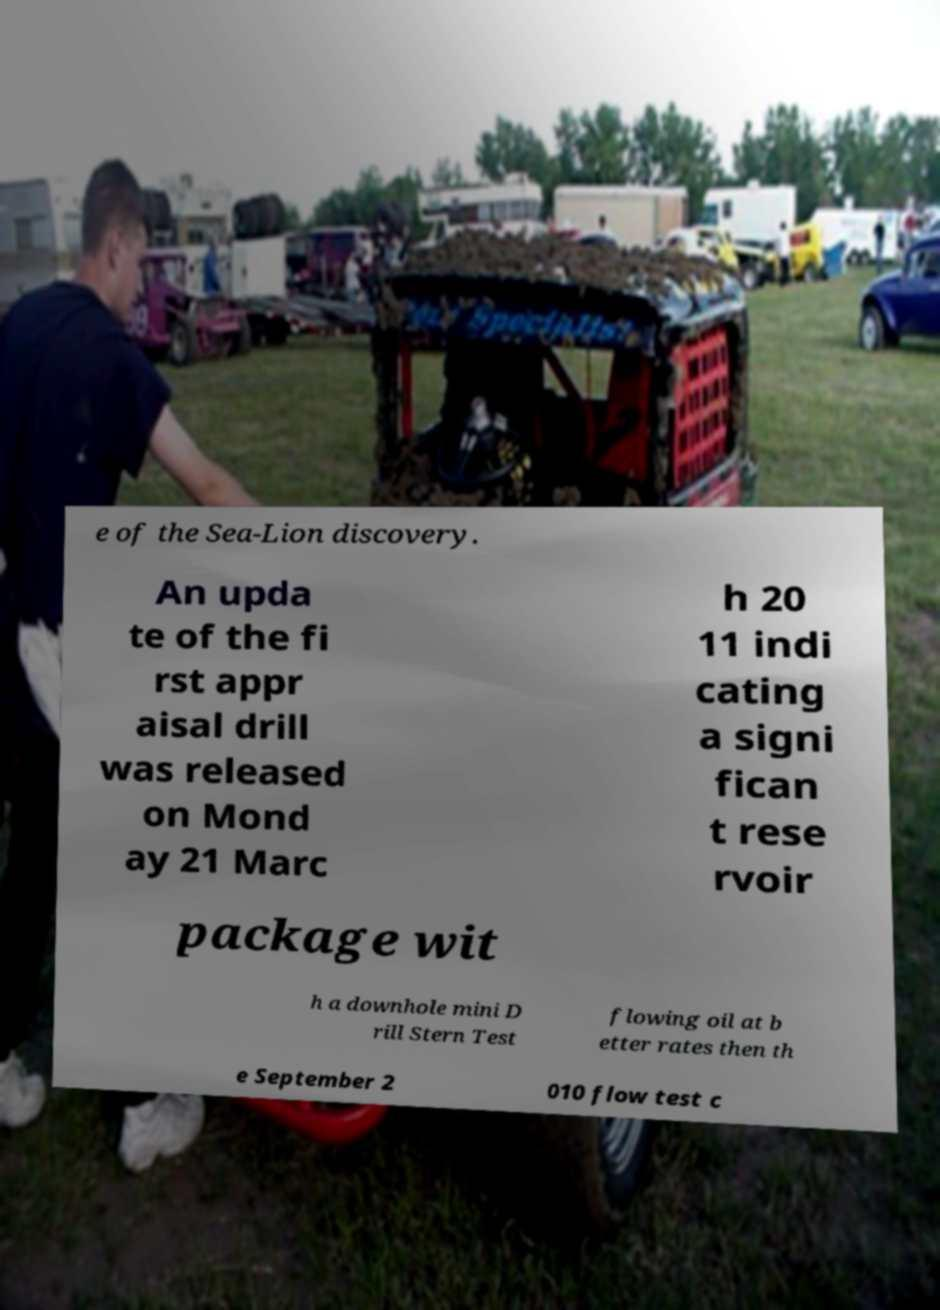Please read and relay the text visible in this image. What does it say? e of the Sea-Lion discovery. An upda te of the fi rst appr aisal drill was released on Mond ay 21 Marc h 20 11 indi cating a signi fican t rese rvoir package wit h a downhole mini D rill Stern Test flowing oil at b etter rates then th e September 2 010 flow test c 